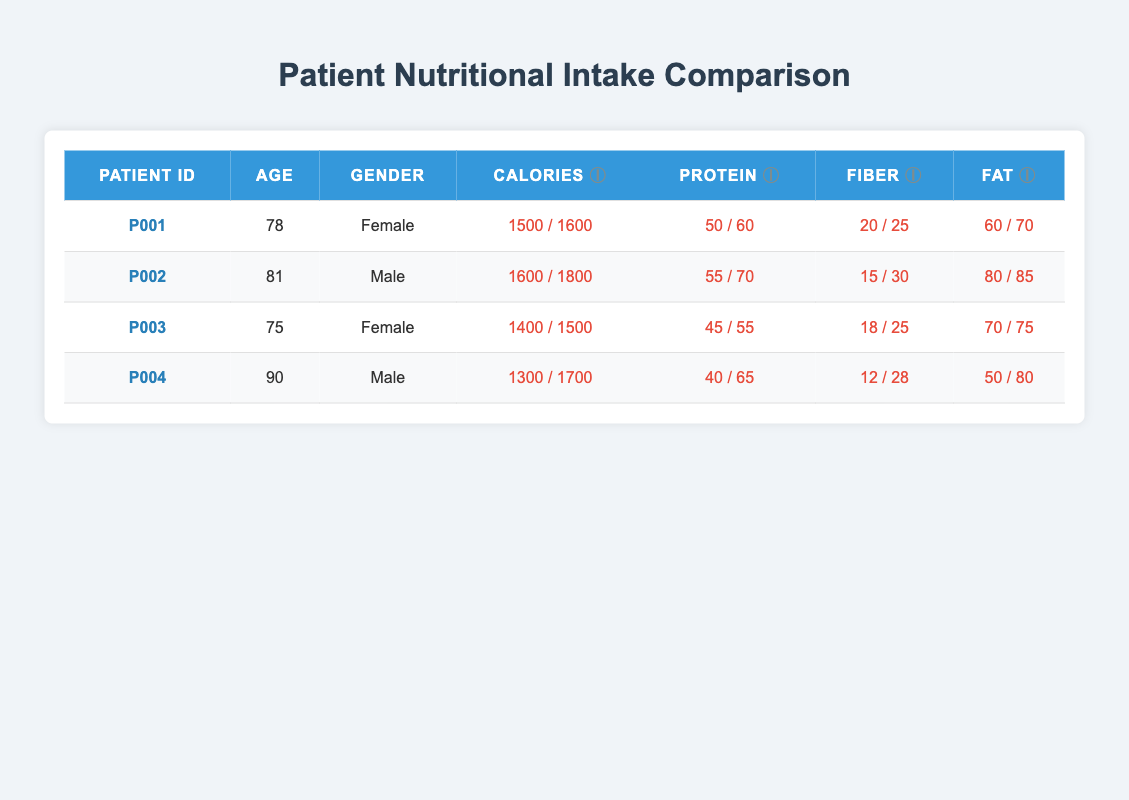What is the caloric intake for patient P001? The table lists the caloric intake for patient P001 in the column under "Calories." It shows a value of 1500, with the dietary guideline being 1600. Therefore, the caloric intake for patient P001 is 1500.
Answer: 1500 Which patient has the lowest protein intake relative to their guideline? For each patient, we compare their protein intake (shown in the second column from the right) against their respective dietary guidelines. Patient P004 has a protein intake of 40 grams and should consume 65 grams according to guidelines, making it the lowest relative intake.
Answer: P004 Calculate the average fiber intake among all patients. Summing the fiber intakes from the table gives: 20 + 15 + 18 + 12 = 65 grams. There are 4 patients, so to find the average, we calculate 65 / 4 = 16.25.
Answer: 16.25 Is patient P002 exceeding their caloric guideline? The caloric intake for patient P002 is listed as 1600, while the dietary guideline is 1800. Since 1600 is less than 1800, patient P002 is not exceeding their caloric guideline.
Answer: No What is the difference between the protein intake for patient P003 and the dietary guideline for protein? Patient P003 has a protein intake of 45 grams, while the dietary guideline requires 55 grams. The difference is calculated by subtracting the intake from the guideline: 55 - 45 = 10 grams.
Answer: 10 Which patient's fat intake is the closest to their dietary guideline? To find out whose fat intake is closest to the guideline, we compare the fat intake and guideline for each patient: P001 has a difference of 10, P002 has a difference of 5, P003 has a difference of 5, and P004 has a difference of 30. Both P002 and P003 have the least difference of 5, so they are the closest.
Answer: P002 and P003 How many patients have a fiber intake below their dietary guideline? By reviewing the fiber intake in the table, we see that patients P001, P002, P003, and P004 all report fiber intakes below the dietary guidelines, which are 25, 30, 25, and 28, respectively. Hence, all 4 patients are below their guidelines.
Answer: 4 Which gender has lower average caloric intake? To find the average caloric intake by gender, we first sum the values: females P001 and P003 have a total of 1500 + 1400 = 2900 (average 1450) and males P002 and P004 have a total of 1600 + 1300 = 2900 (average 1450). Both genders have the same average caloric intake of 1450, indicating no lower average for either gender.
Answer: Neither Does patient P004 meet any nutritional guidelines? Evaluating patient P004's intake against guidelines, we see that their caloric intake is 1300 against 1700, protein intake is 40 against 65, fiber intake is 12 against 28, and fat intake is 50 against 80. All values are below the guidelines, which means patient P004 does not meet any nutritional guidelines.
Answer: No 